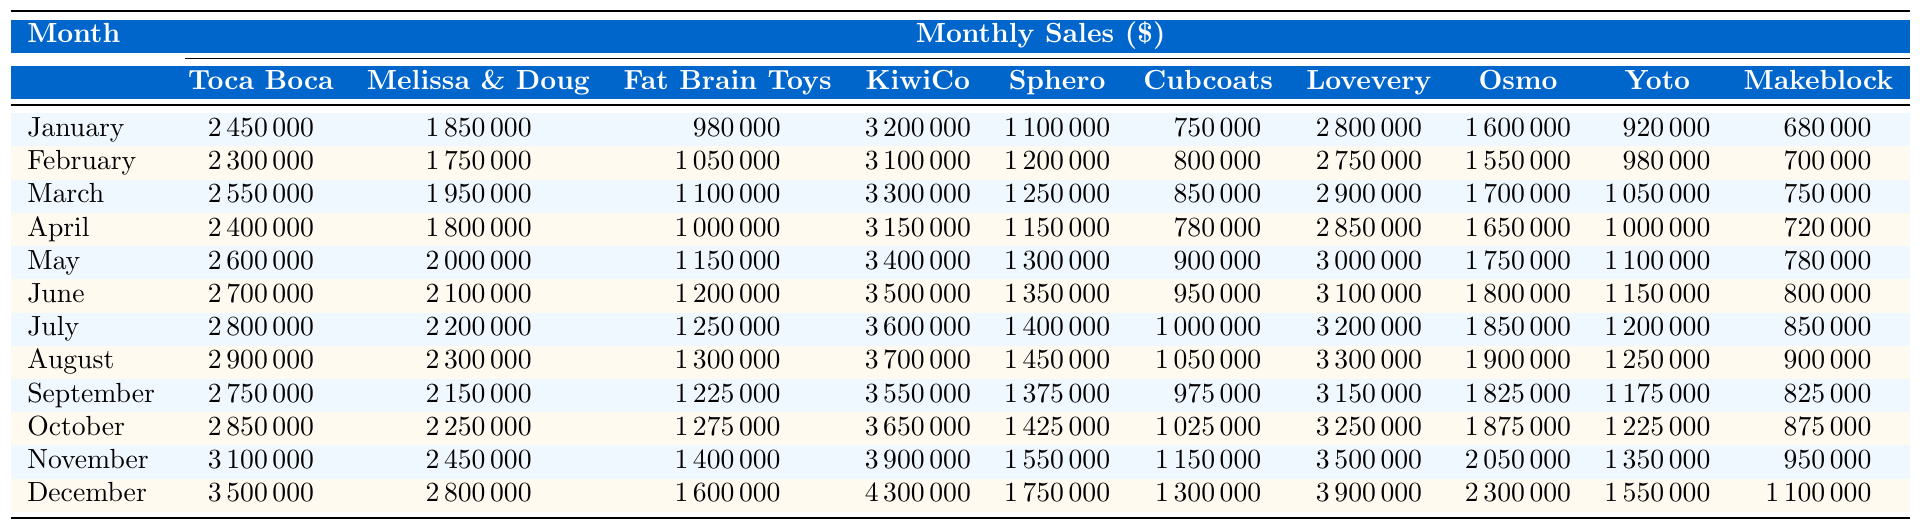What was the highest monthly sales figure for Toca Boca in 2022? The highest monthly sales figure for Toca Boca can be found by looking through the values in the Toca Boca column. Reviewing the data, the highest value is in December at 3,500,000.
Answer: 3,500,000 Which toy startup had the lowest sales in January? In January, we check the sales figures across all startups to find the lowest value. The lowest sales figure is 680,000, which belongs to Makeblock.
Answer: Makeblock What was the total sales for KiwiCo from January to December? To calculate the total sales for KiwiCo, we sum all the monthly sales figures in the KiwiCo column. The total is calculated as (3,200,000 + 3,100,000 + 3,300,000 + 3,150,000 + 3,400,000 + 3,500,000 + 3,600,000 + 3,700,000 + 3,550,000 + 3,650,000 + 3,900,000 + 4,300,000) = 39,950,000.
Answer: 39,950,000 In which month did Lovevery have sales exceeding 3 million? By examining the Lovevery column for months where sales were greater than 3,000,000, we see that November and December are the only months that exceed that threshold at 3,500,000 and 3,900,000 respectively. Therefore, the months are November and December.
Answer: November and December Did Melissa & Doug's sales decrease in September compared to August? To find this, we compare the sales figures for Melissa & Doug in September (2,150,000) and August (2,300,000). Since 2,150,000 is less than 2,300,000, the sales did decrease.
Answer: Yes What is the average monthly sales figure for Fat Brain Toys in 2022? To find the average, we first sum the monthly sales for Fat Brain Toys (980,000 + 1,050,000 + 1,100,000 + 1,000,000 + 1,150,000 + 1,200,000 + 1,250,000 + 1,300,000 + 1,225,000 + 1,275,000 + 1,400,000 + 1,600,000) which equals 14,275,000. Dividing this by 12 gives an average of 1,189,583.33.
Answer: 1,189,583.33 Which toy startup had the largest sales increase from January to December? To determine the largest sales increase, we subtract the January sales from the December sales for each startup. For example, Toca Boca shows an increase of 1,050,000 (3,500,000 - 2,450,000), Melissa & Doug shows 950,000 (2,800,000 - 1,850,000), and so on. After calculating for all, KiwiCo has the largest increase of 1,100,000 (4,300,000 - 3,200,000).
Answer: KiwiCo What percentage of total sales for December does Yoto represent? First, we find the total sales for December by summing sales for all startups, which is 20,400,000. Then we find Yoto's sales for December, which is 1,550,000. The percentage is calculated as (1,550,000 / 20,400,000) * 100, resulting in approximately 7.6%.
Answer: 7.6% Which month had the least total sales across all startups? We sum the sales for each month: January (19,000,000), February (18,900,000), and so on. After calculating each month, we find that January has the least total sales of 19,000,000.
Answer: January Is there a month where all startups had sales figures exceeding 2 million? We assess each month to see if every startup had sales over 2 million in that month. In December, all startups exceeded 2 million, making it the month with sales exceeding 2 million for all.
Answer: Yes 